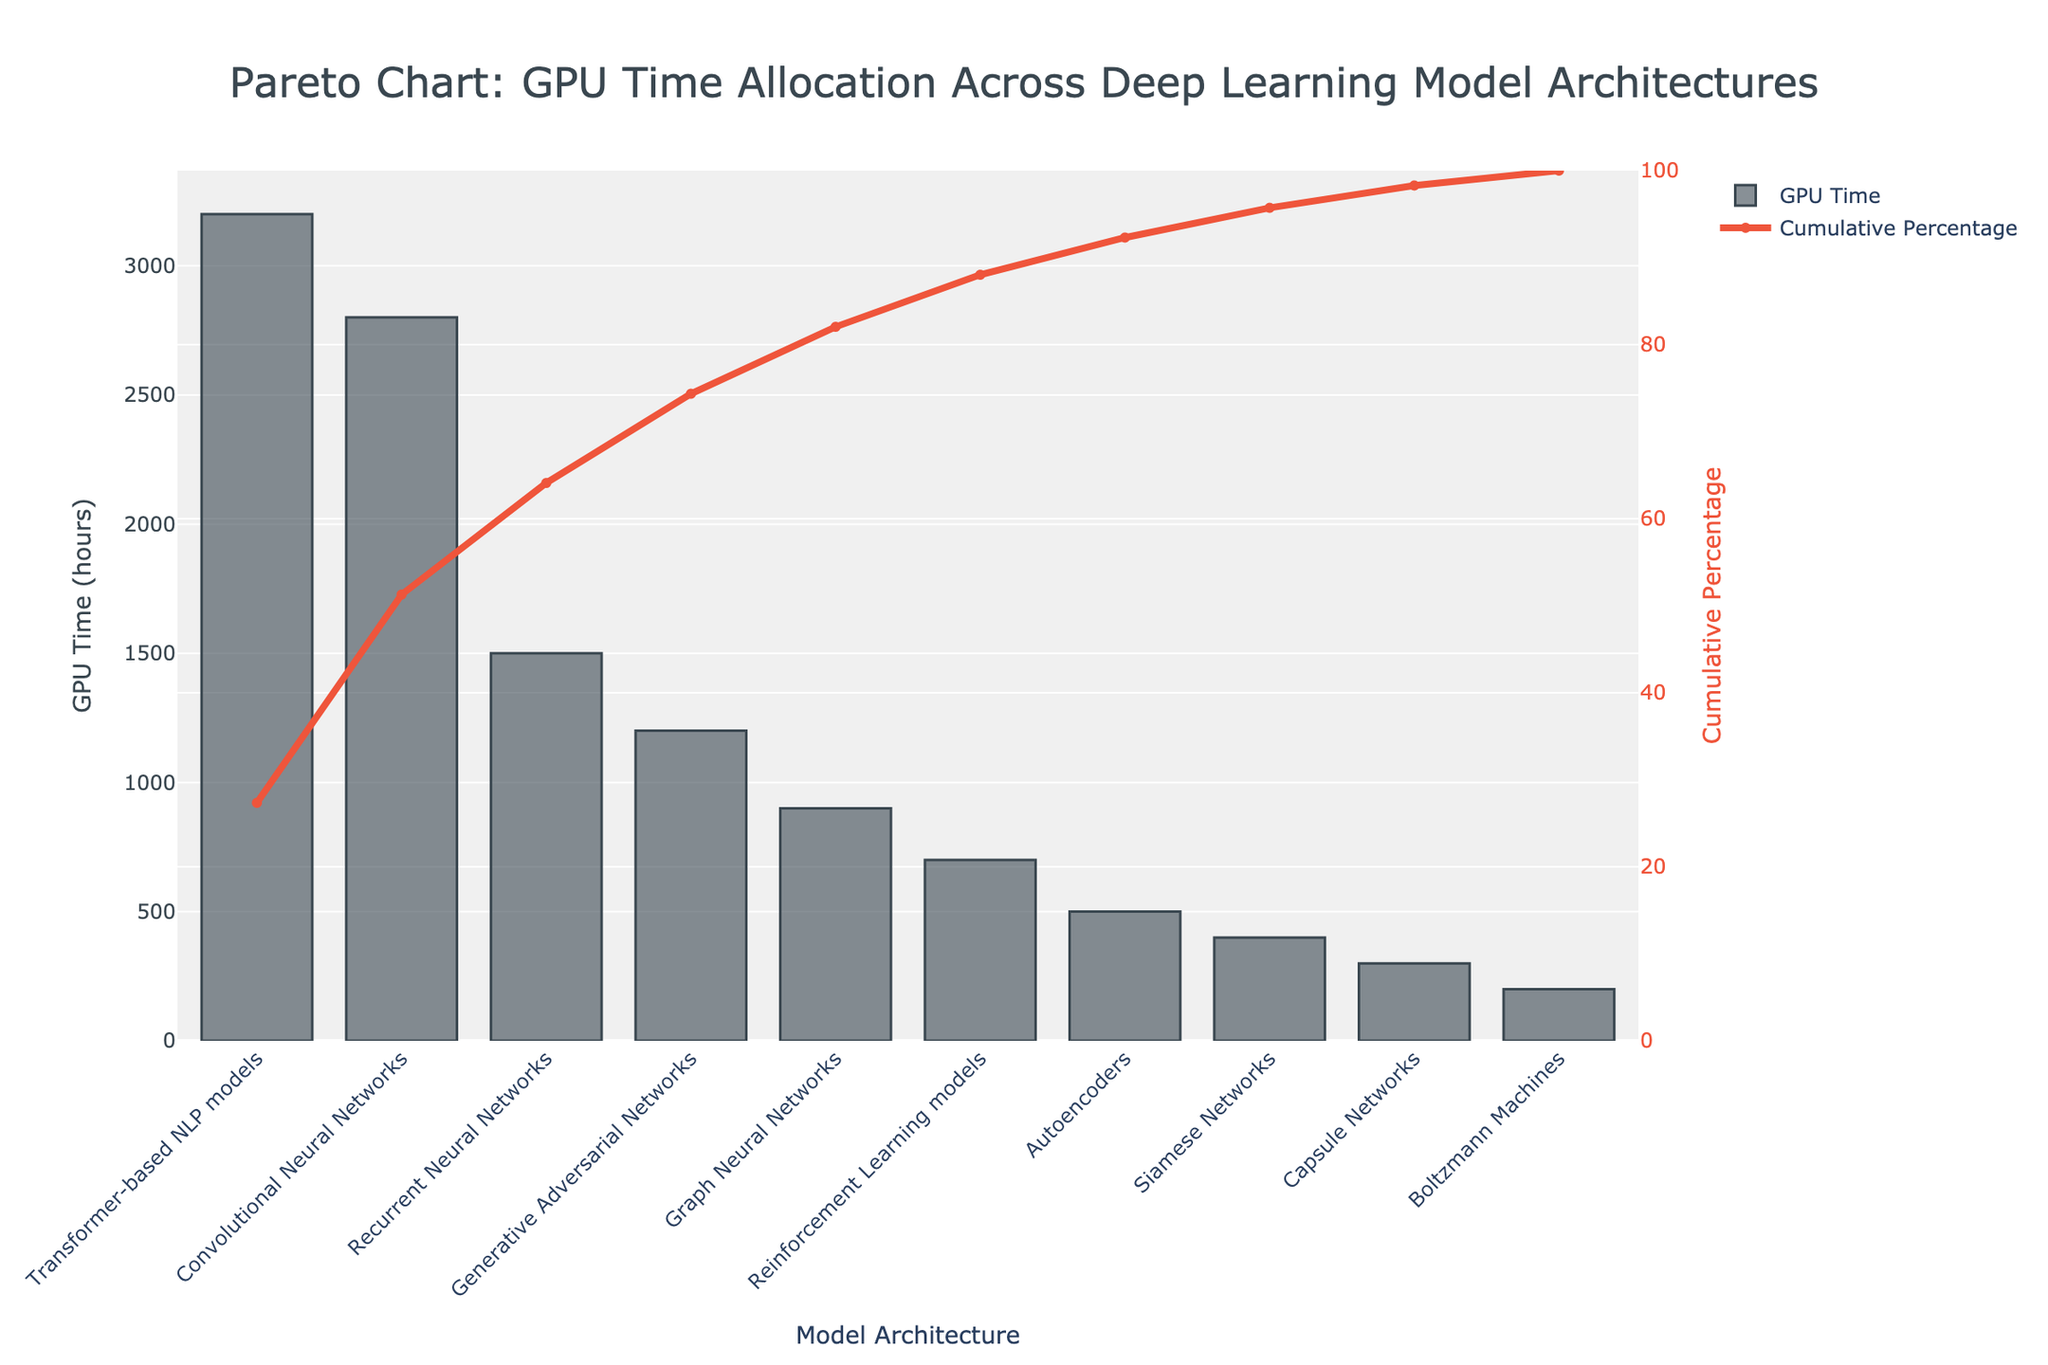What's the title of the figure? The title is visible at the top of the figure and it outlines the main subject of the chart.
Answer: Pareto Chart: GPU Time Allocation Across Deep Learning Model Architectures Which model architecture consumes the most GPU time? The highest bar in the bar chart indicates the model architecture with the largest GPU time allocation.
Answer: Transformer-based NLP models What is the cumulative percentage of GPU time at "Reinforcement Learning models"? Follow the cumulative percentage line on the right y-axis up to the "Reinforcement Learning models" category on the x-axis and read the value.
Answer: 94% How many model architectures cumulatively use 80% of the GPU time? Look at the cumulative percentage line and find the point closest to 80%. Count the number of model architectures up to that point.
Answer: Four What is the total GPU time for the top three model architectures combined? Add the GPU times of the top three model architectures: Transformer-based NLP models, Convolutional Neural Networks, and Recurrent Neural Networks. 3200 + 2800 + 1500
Answer: 7500 hours Which model architecture has the lowest GPU time allocation? The shortest bar in the bar chart indicates the model architecture with the smallest GPU time allocation.
Answer: Boltzmann Machines What is the GPU time difference between Convolutional Neural Networks and Recurrent Neural Networks? Subtract the GPU time for Recurrent Neural Networks from the GPU time for Convolutional Neural Networks. 2800 - 1500
Answer: 1300 hours How does the GPU time allocated to Autoencoders compare to that of Generative Adversarial Networks (GANs)? Compare the heights of the bars for Autoencoders and GANs. Autoencoders have 500 hours and GANs have 1200 hours, so GANs have more GPU time allocated.
Answer: GANs have more GPU time than Autoencoders What is the cumulative percentage after including Transformer-based NLP models and Convolutional Neural Networks? Check the cumulative percentage line after adding Transformer-based NLP models and Convolutional Neural Networks, and read the corresponding value.
Answer: 53% How many model architectures are shown in the figure? Count the number of bars or labels on the x-axis.
Answer: Ten 